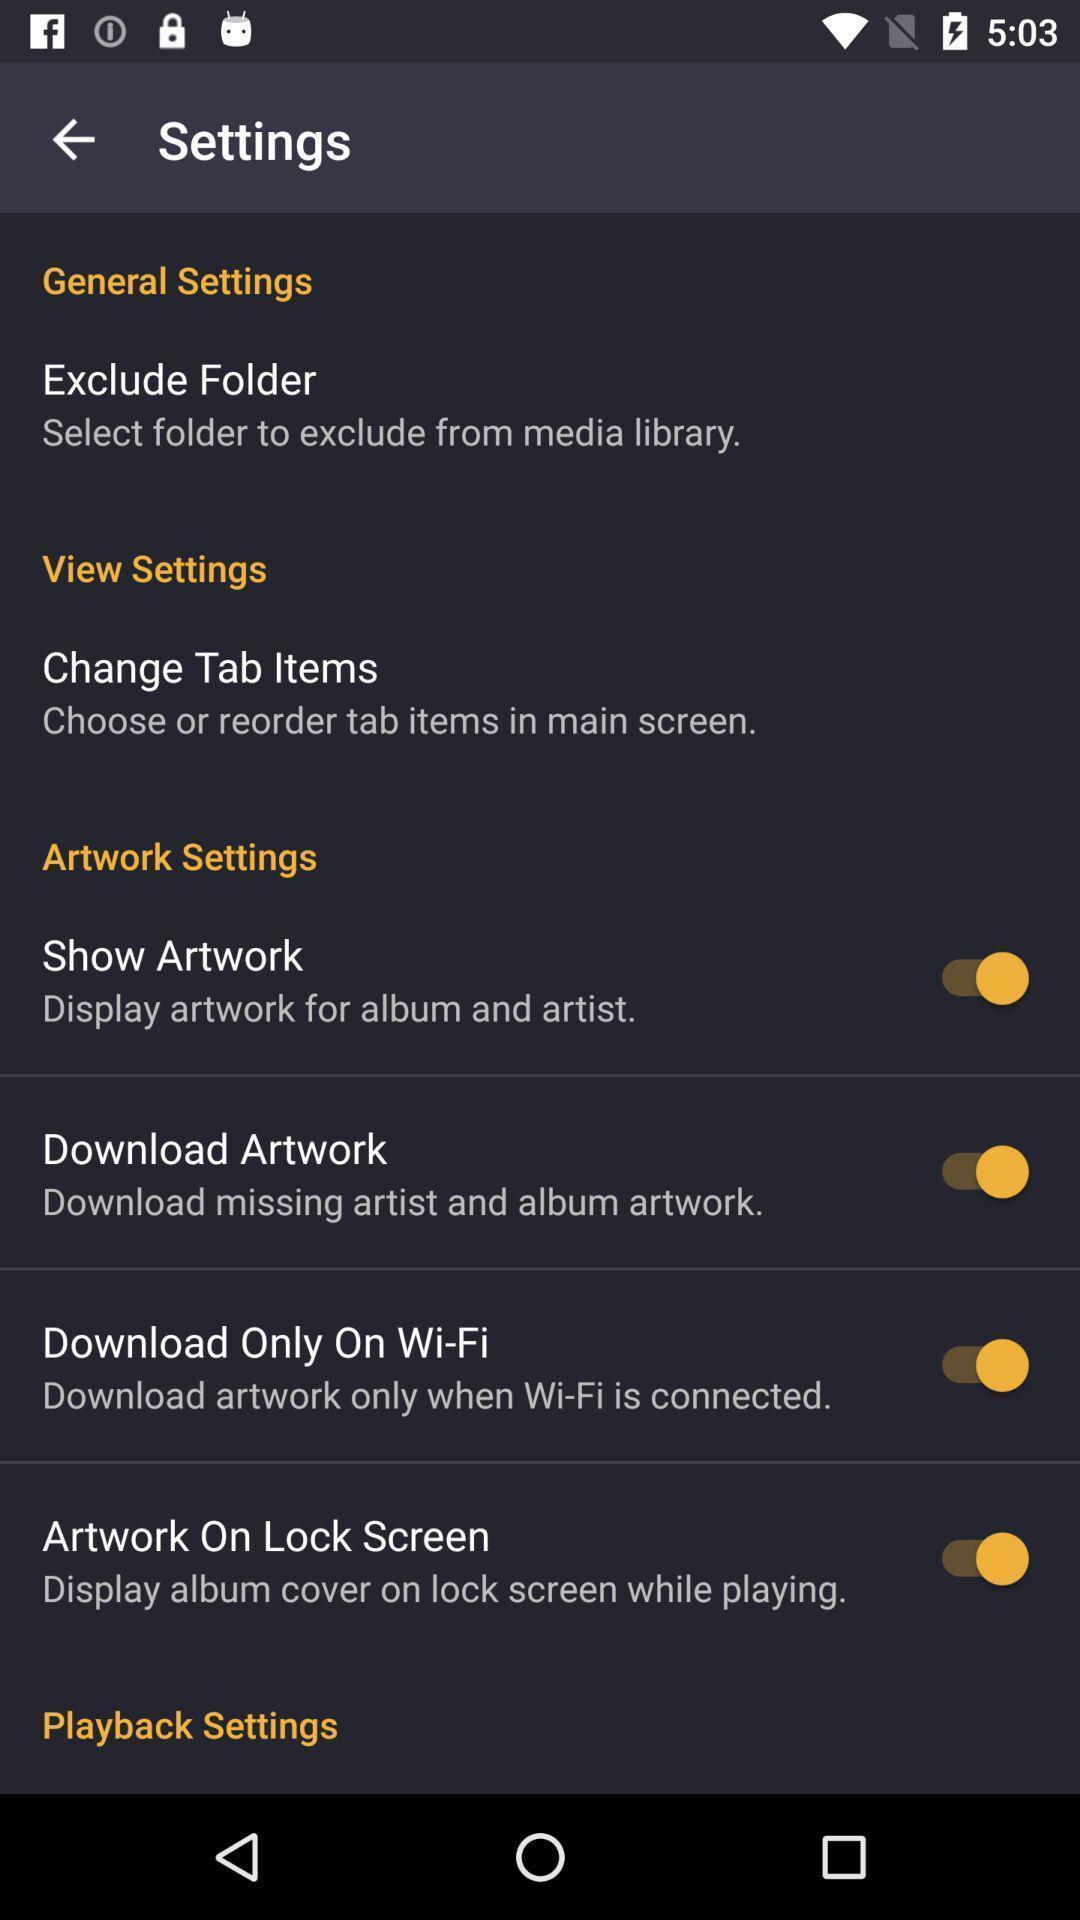What can you discern from this picture? Page showing the options in settings tab. 